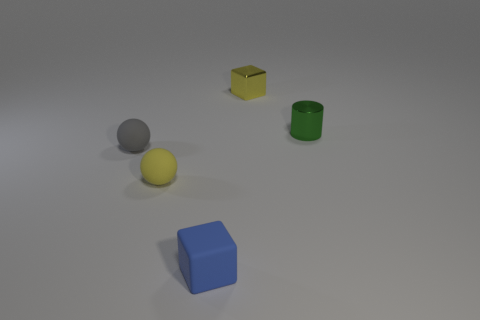Add 4 gray matte things. How many objects exist? 9 Subtract all spheres. How many objects are left? 3 Add 3 yellow metal cubes. How many yellow metal cubes exist? 4 Subtract 0 purple spheres. How many objects are left? 5 Subtract all small green shiny balls. Subtract all green objects. How many objects are left? 4 Add 4 small objects. How many small objects are left? 9 